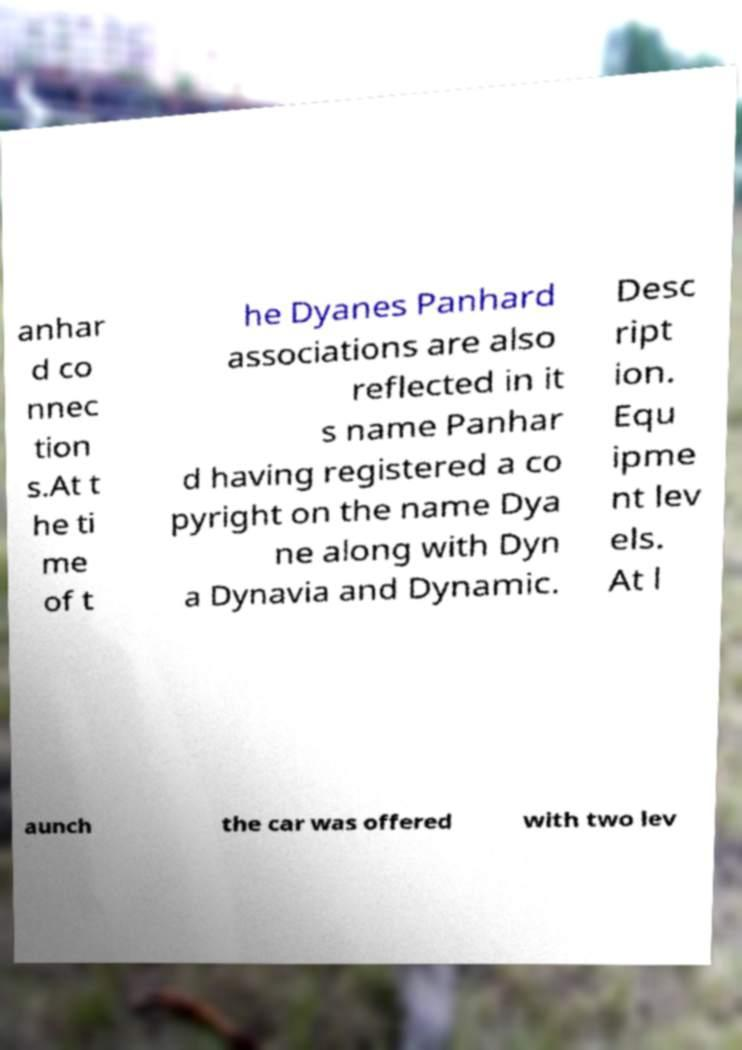Can you read and provide the text displayed in the image?This photo seems to have some interesting text. Can you extract and type it out for me? anhar d co nnec tion s.At t he ti me of t he Dyanes Panhard associations are also reflected in it s name Panhar d having registered a co pyright on the name Dya ne along with Dyn a Dynavia and Dynamic. Desc ript ion. Equ ipme nt lev els. At l aunch the car was offered with two lev 